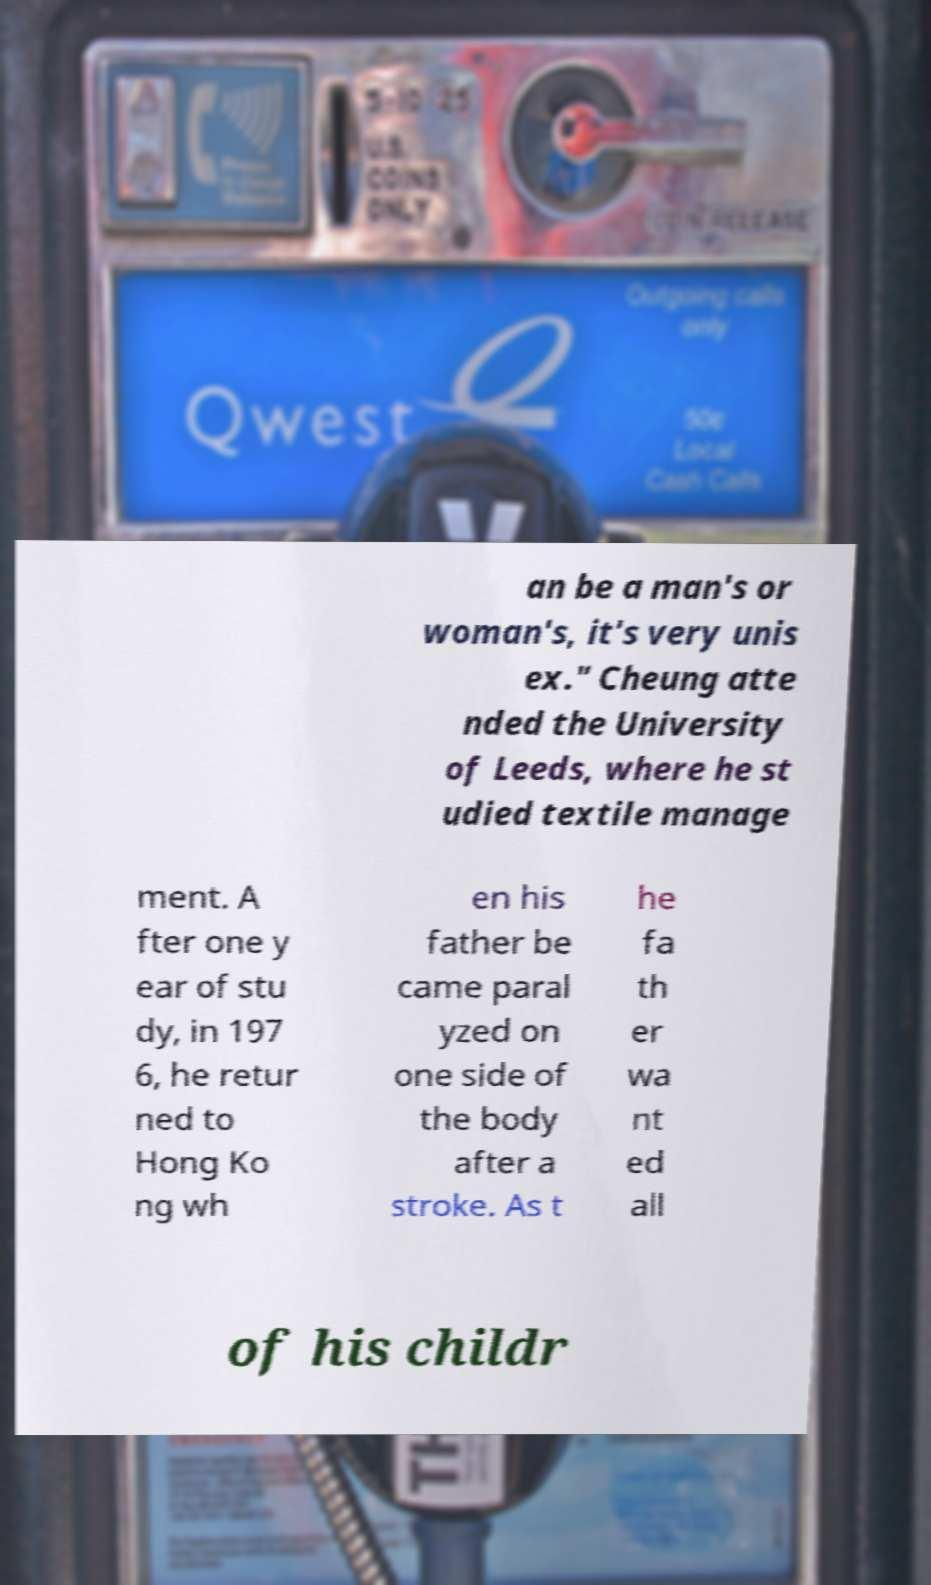For documentation purposes, I need the text within this image transcribed. Could you provide that? an be a man's or woman's, it's very unis ex." Cheung atte nded the University of Leeds, where he st udied textile manage ment. A fter one y ear of stu dy, in 197 6, he retur ned to Hong Ko ng wh en his father be came paral yzed on one side of the body after a stroke. As t he fa th er wa nt ed all of his childr 